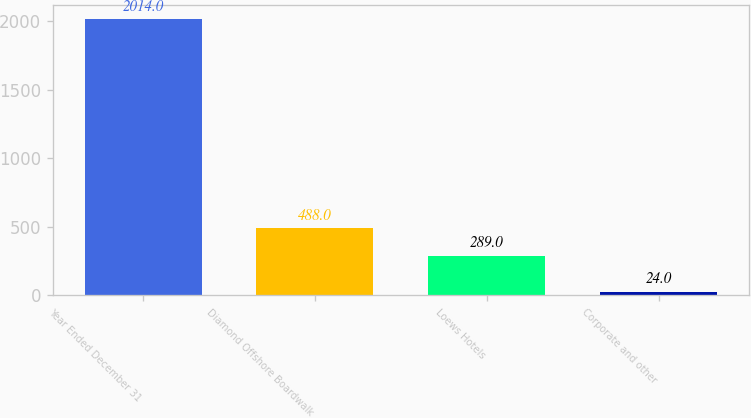<chart> <loc_0><loc_0><loc_500><loc_500><bar_chart><fcel>Year Ended December 31<fcel>Diamond Offshore Boardwalk<fcel>Loews Hotels<fcel>Corporate and other<nl><fcel>2014<fcel>488<fcel>289<fcel>24<nl></chart> 